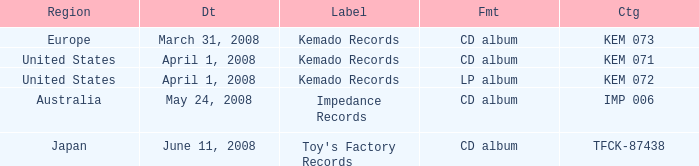Which Format has a Region of united states, and a Catalog of kem 072? LP album. 